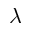Convert formula to latex. <formula><loc_0><loc_0><loc_500><loc_500>\lambda</formula> 